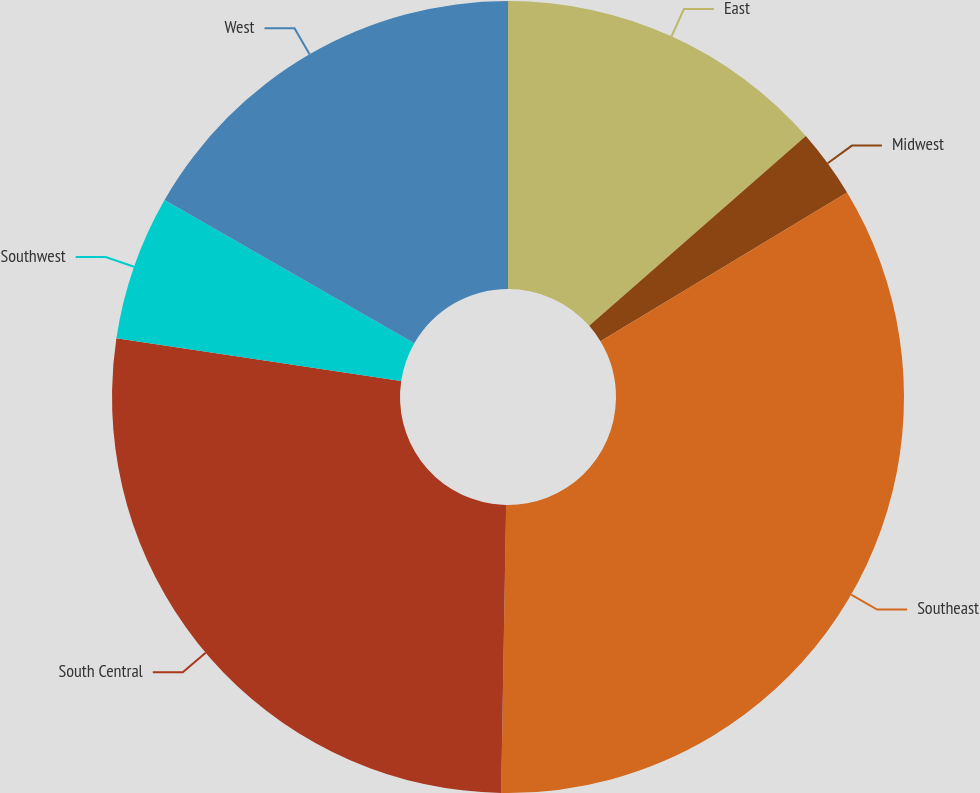Convert chart to OTSL. <chart><loc_0><loc_0><loc_500><loc_500><pie_chart><fcel>East<fcel>Midwest<fcel>Southeast<fcel>South Central<fcel>Southwest<fcel>West<nl><fcel>13.55%<fcel>2.81%<fcel>33.92%<fcel>27.1%<fcel>5.92%<fcel>16.71%<nl></chart> 